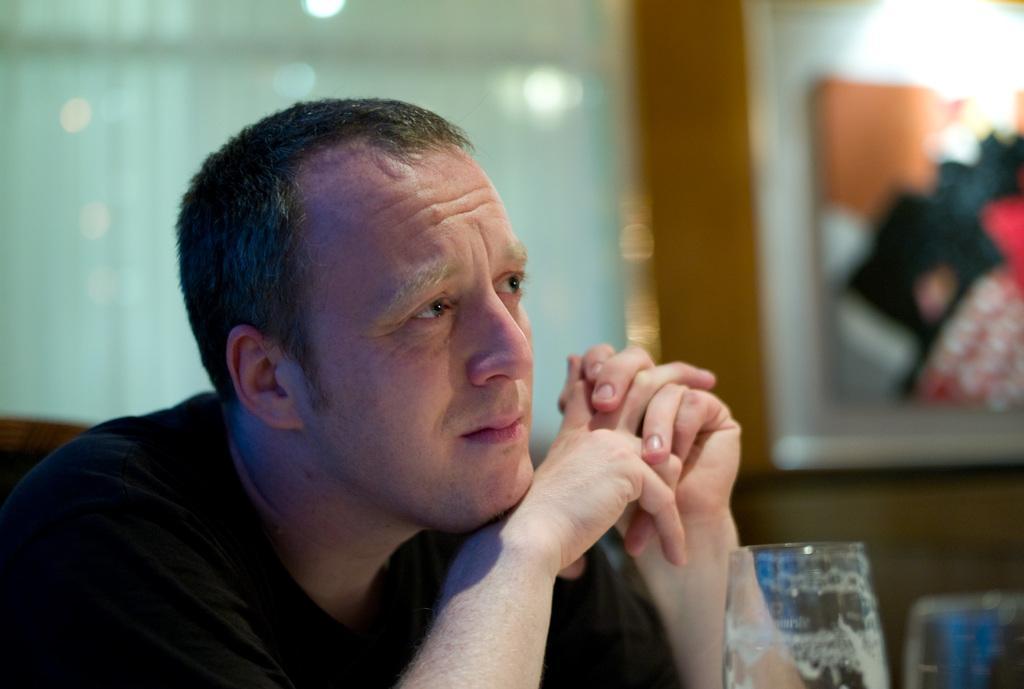Describe this image in one or two sentences. In this image there is a man. In front of him there are glasses. Behind him there is a wall. There are window blinds and a picture frame on the wall. 